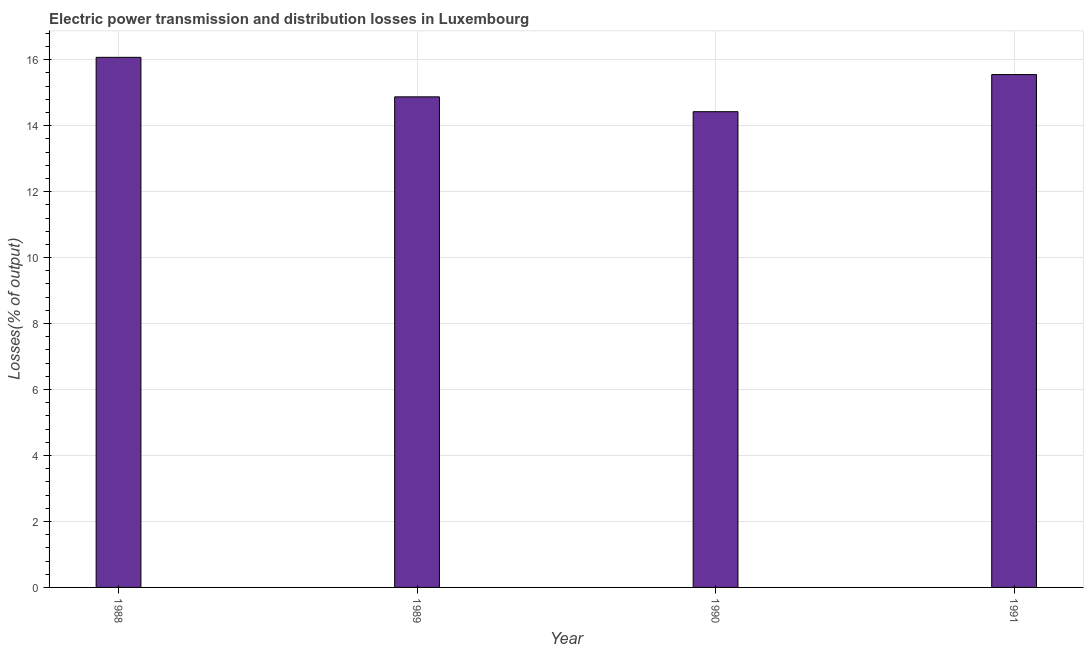Does the graph contain any zero values?
Keep it short and to the point. No. What is the title of the graph?
Provide a short and direct response. Electric power transmission and distribution losses in Luxembourg. What is the label or title of the X-axis?
Offer a very short reply. Year. What is the label or title of the Y-axis?
Offer a very short reply. Losses(% of output). What is the electric power transmission and distribution losses in 1988?
Keep it short and to the point. 16.07. Across all years, what is the maximum electric power transmission and distribution losses?
Give a very brief answer. 16.07. Across all years, what is the minimum electric power transmission and distribution losses?
Provide a succinct answer. 14.42. In which year was the electric power transmission and distribution losses maximum?
Give a very brief answer. 1988. In which year was the electric power transmission and distribution losses minimum?
Your response must be concise. 1990. What is the sum of the electric power transmission and distribution losses?
Offer a terse response. 60.92. What is the difference between the electric power transmission and distribution losses in 1988 and 1991?
Provide a succinct answer. 0.52. What is the average electric power transmission and distribution losses per year?
Give a very brief answer. 15.23. What is the median electric power transmission and distribution losses?
Give a very brief answer. 15.21. Do a majority of the years between 1991 and 1989 (inclusive) have electric power transmission and distribution losses greater than 5.2 %?
Offer a terse response. Yes. What is the ratio of the electric power transmission and distribution losses in 1988 to that in 1989?
Your answer should be compact. 1.08. What is the difference between the highest and the second highest electric power transmission and distribution losses?
Your answer should be compact. 0.52. Is the sum of the electric power transmission and distribution losses in 1989 and 1991 greater than the maximum electric power transmission and distribution losses across all years?
Your answer should be compact. Yes. What is the difference between the highest and the lowest electric power transmission and distribution losses?
Offer a terse response. 1.65. How many bars are there?
Provide a succinct answer. 4. Are all the bars in the graph horizontal?
Provide a succinct answer. No. How many years are there in the graph?
Your answer should be very brief. 4. What is the difference between two consecutive major ticks on the Y-axis?
Provide a short and direct response. 2. Are the values on the major ticks of Y-axis written in scientific E-notation?
Offer a terse response. No. What is the Losses(% of output) in 1988?
Provide a short and direct response. 16.07. What is the Losses(% of output) in 1989?
Offer a terse response. 14.87. What is the Losses(% of output) of 1990?
Provide a short and direct response. 14.42. What is the Losses(% of output) of 1991?
Offer a terse response. 15.55. What is the difference between the Losses(% of output) in 1988 and 1989?
Keep it short and to the point. 1.2. What is the difference between the Losses(% of output) in 1988 and 1990?
Make the answer very short. 1.65. What is the difference between the Losses(% of output) in 1988 and 1991?
Give a very brief answer. 0.52. What is the difference between the Losses(% of output) in 1989 and 1990?
Offer a terse response. 0.45. What is the difference between the Losses(% of output) in 1989 and 1991?
Provide a succinct answer. -0.68. What is the difference between the Losses(% of output) in 1990 and 1991?
Give a very brief answer. -1.13. What is the ratio of the Losses(% of output) in 1988 to that in 1989?
Your answer should be very brief. 1.08. What is the ratio of the Losses(% of output) in 1988 to that in 1990?
Offer a very short reply. 1.11. What is the ratio of the Losses(% of output) in 1988 to that in 1991?
Your answer should be very brief. 1.03. What is the ratio of the Losses(% of output) in 1989 to that in 1990?
Offer a terse response. 1.03. What is the ratio of the Losses(% of output) in 1989 to that in 1991?
Keep it short and to the point. 0.96. What is the ratio of the Losses(% of output) in 1990 to that in 1991?
Provide a short and direct response. 0.93. 